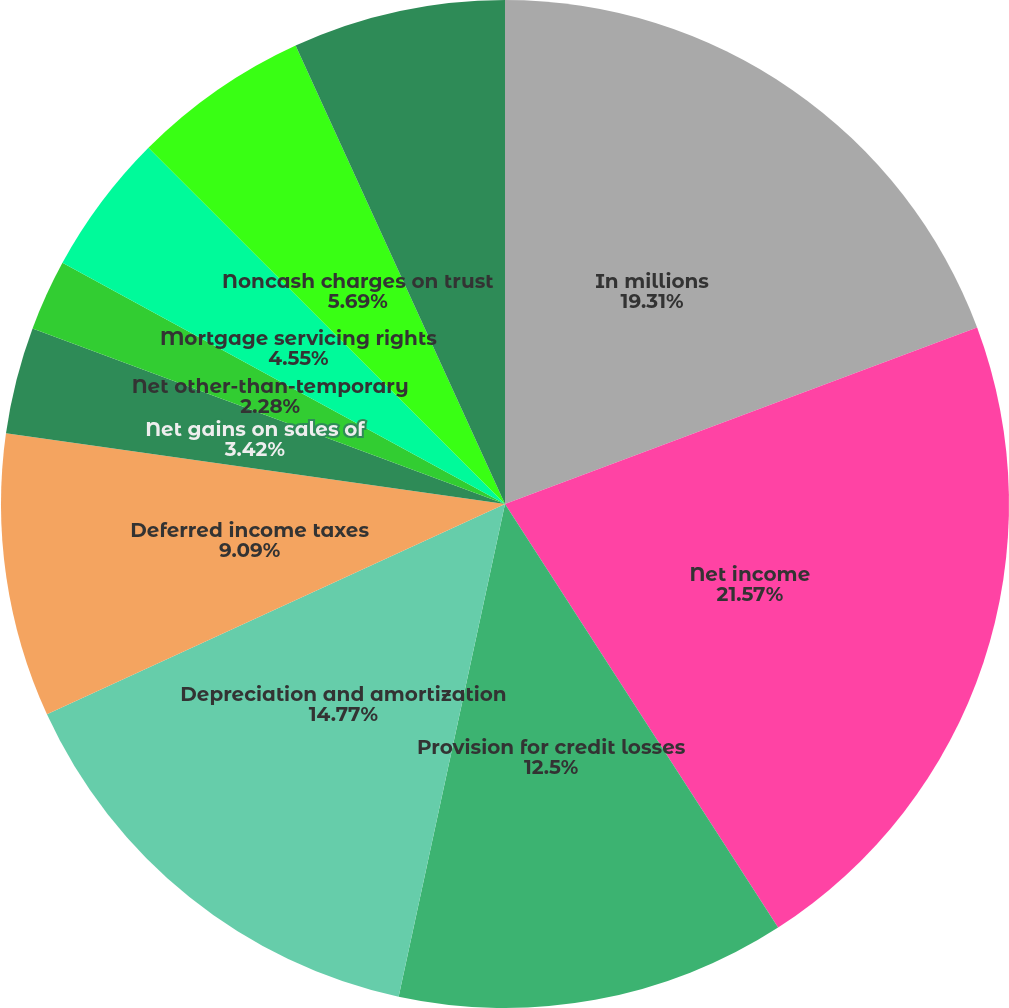Convert chart to OTSL. <chart><loc_0><loc_0><loc_500><loc_500><pie_chart><fcel>In millions<fcel>Net income<fcel>Provision for credit losses<fcel>Depreciation and amortization<fcel>Deferred income taxes<fcel>Net gains on sales of<fcel>Net other-than-temporary<fcel>Mortgage servicing rights<fcel>Noncash charges on trust<fcel>Undistributed earnings of<nl><fcel>19.31%<fcel>21.58%<fcel>12.5%<fcel>14.77%<fcel>9.09%<fcel>3.42%<fcel>2.28%<fcel>4.55%<fcel>5.69%<fcel>6.82%<nl></chart> 